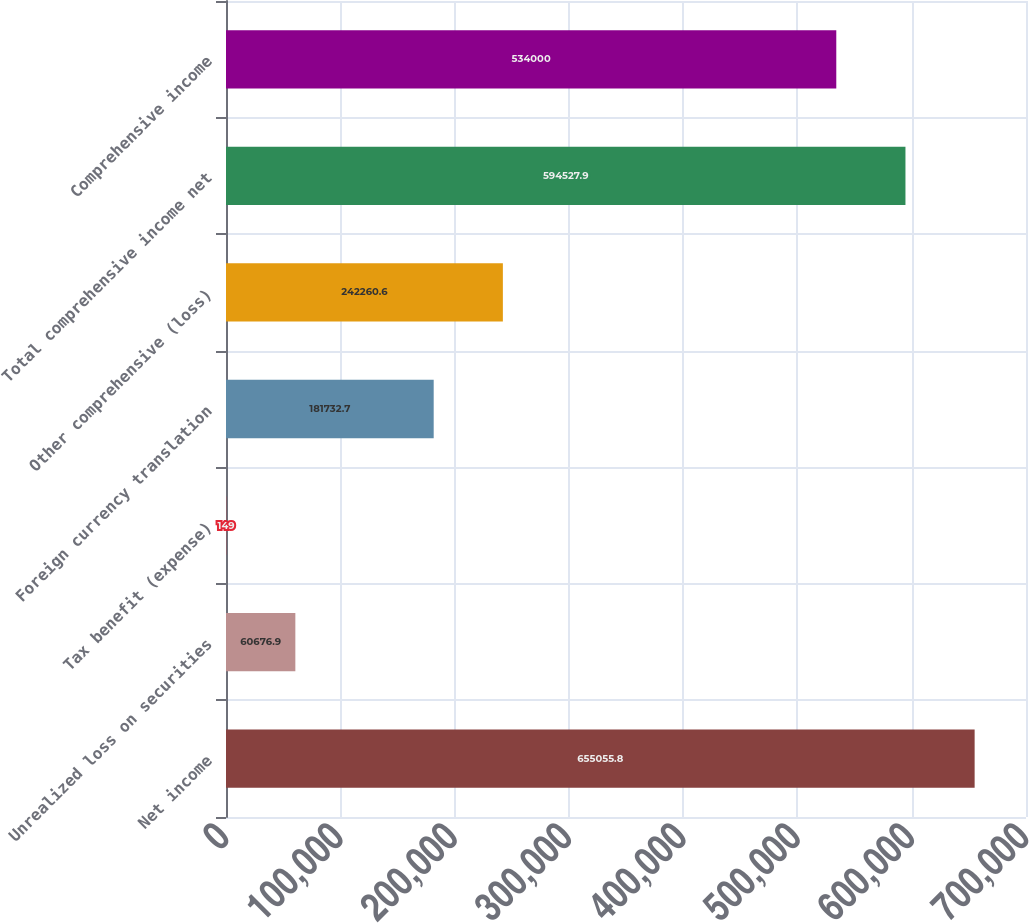Convert chart to OTSL. <chart><loc_0><loc_0><loc_500><loc_500><bar_chart><fcel>Net income<fcel>Unrealized loss on securities<fcel>Tax benefit (expense)<fcel>Foreign currency translation<fcel>Other comprehensive (loss)<fcel>Total comprehensive income net<fcel>Comprehensive income<nl><fcel>655056<fcel>60676.9<fcel>149<fcel>181733<fcel>242261<fcel>594528<fcel>534000<nl></chart> 